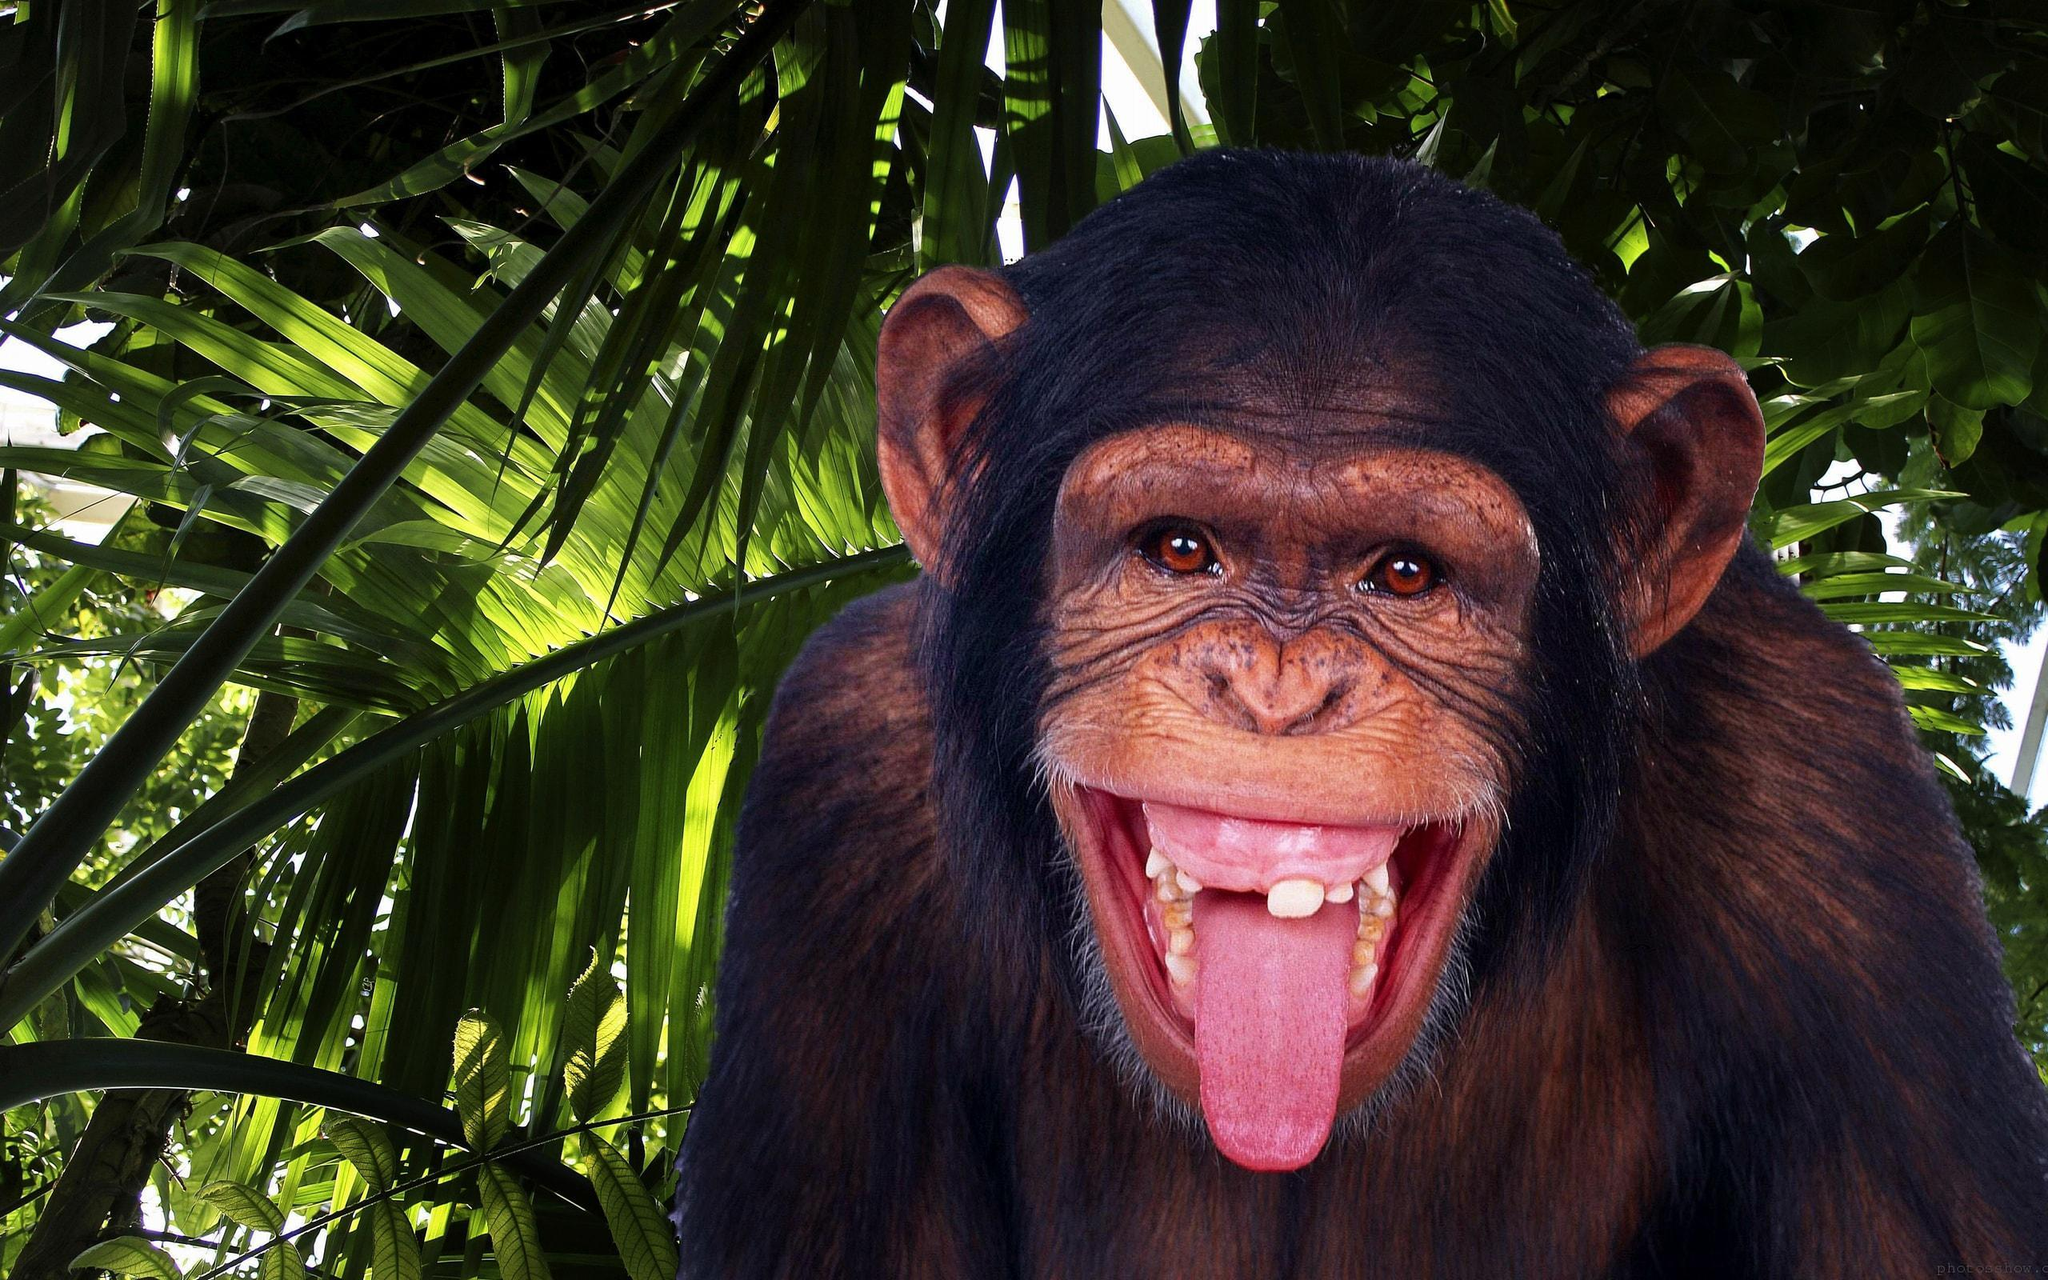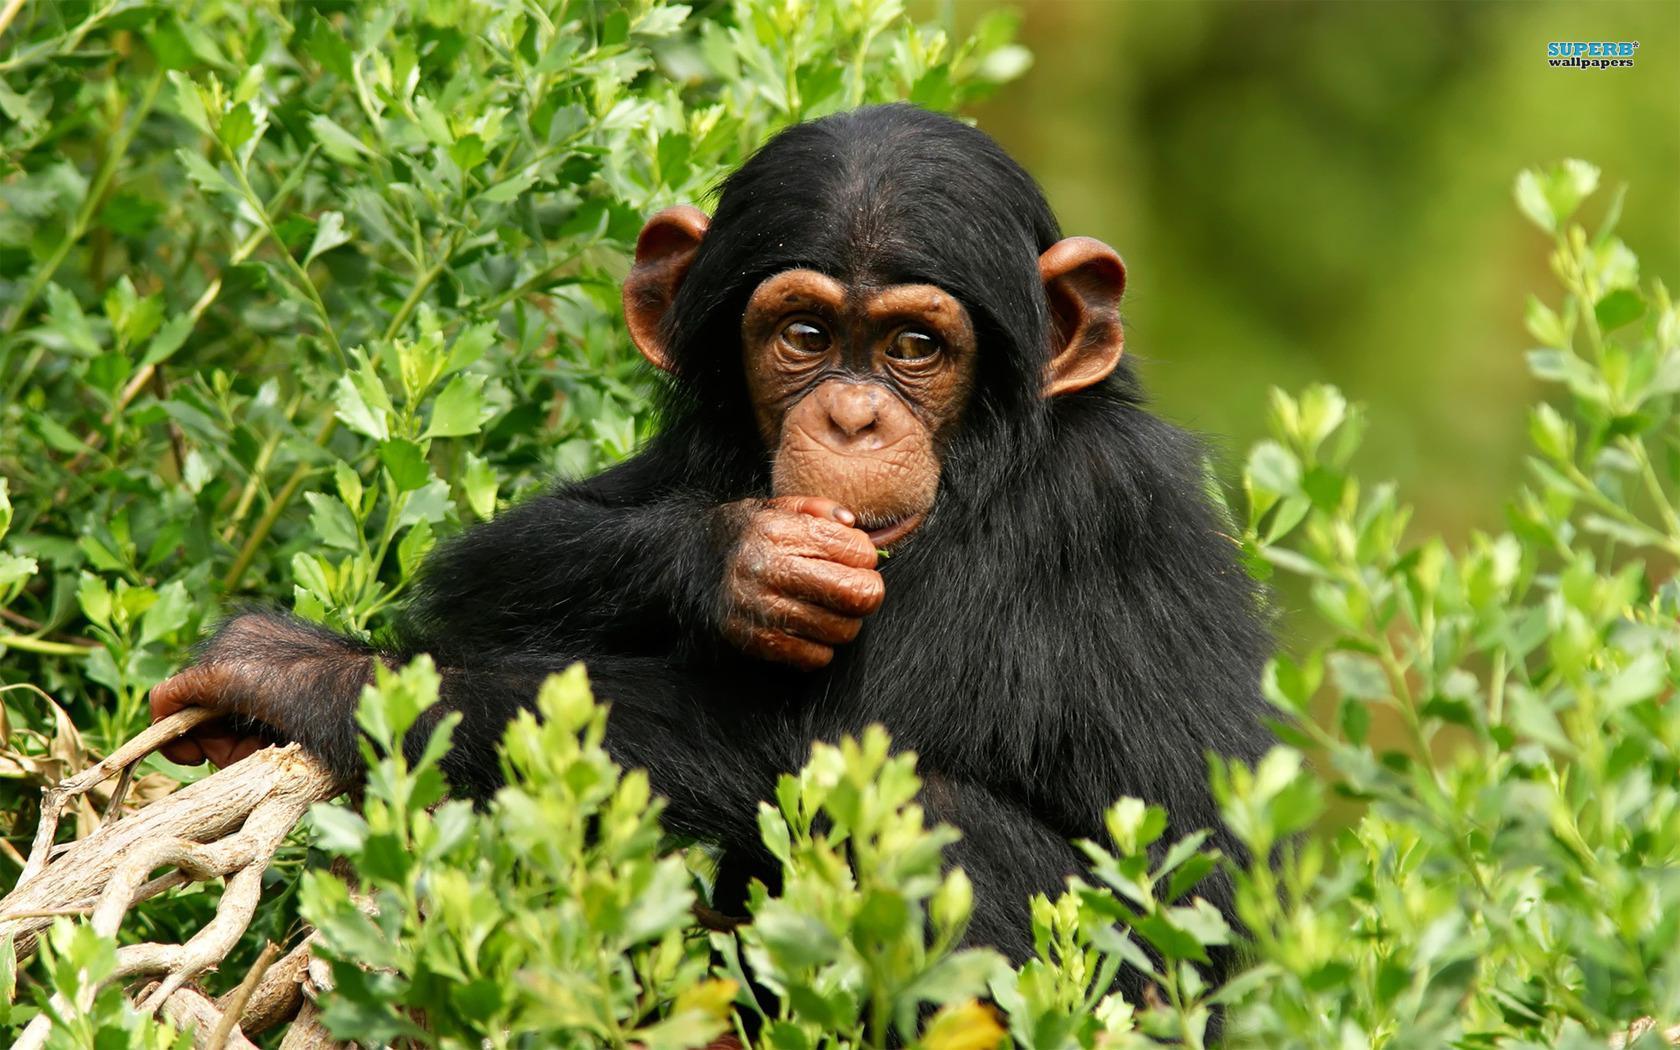The first image is the image on the left, the second image is the image on the right. Considering the images on both sides, is "There are only two monkeys." valid? Answer yes or no. Yes. The first image is the image on the left, the second image is the image on the right. Considering the images on both sides, is "One of the image features more than one monkey." valid? Answer yes or no. No. 